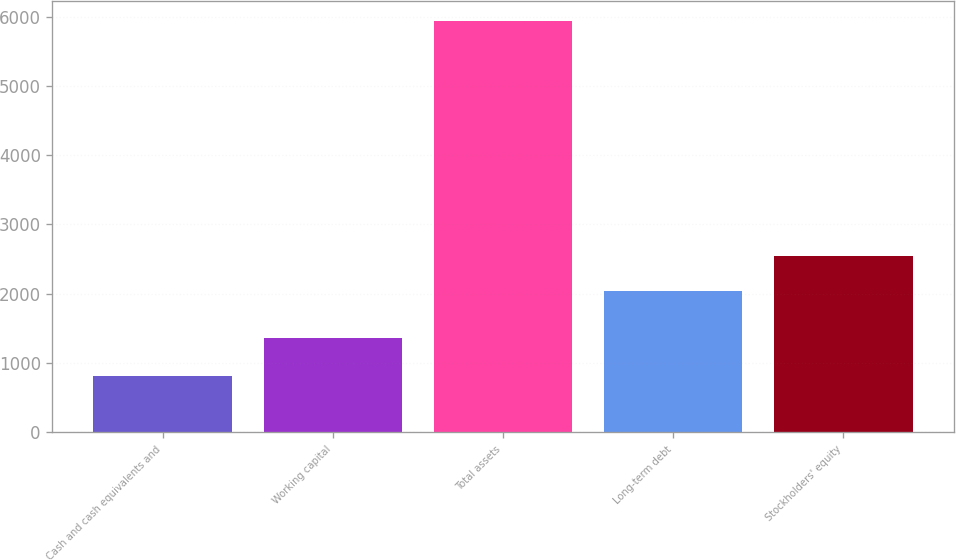<chart> <loc_0><loc_0><loc_500><loc_500><bar_chart><fcel>Cash and cash equivalents and<fcel>Working capital<fcel>Total assets<fcel>Long-term debt<fcel>Stockholders' equity<nl><fcel>818<fcel>1358<fcel>5933<fcel>2038<fcel>2549.5<nl></chart> 